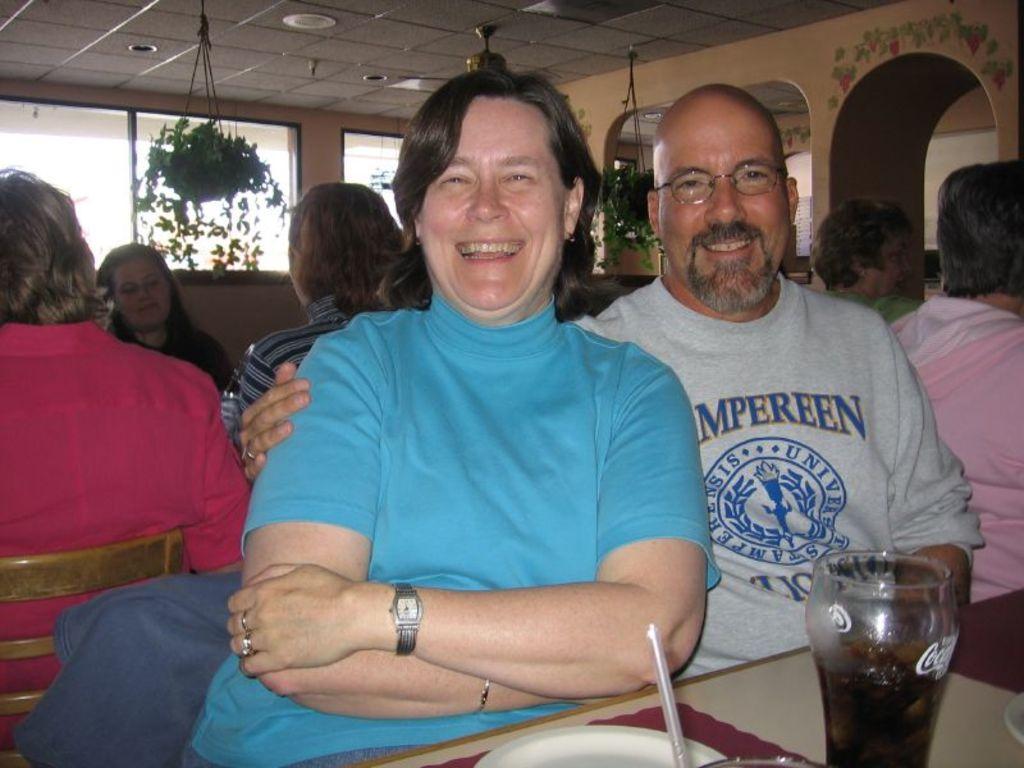How would you summarize this image in a sentence or two? In the image we can see there are people who are sitting in front and they are smiling. On table there is juice glass, plate and at the back other people are sitting. On the top there is a flower pot. 